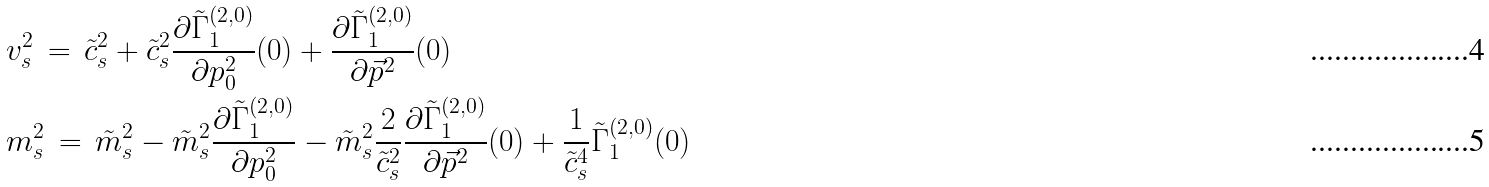Convert formula to latex. <formula><loc_0><loc_0><loc_500><loc_500>& v _ { s } ^ { 2 } \, = \, \tilde { c } _ { s } ^ { 2 } + \tilde { c } _ { s } ^ { 2 } \frac { \partial \tilde { \Gamma } ^ { ( 2 , 0 ) } _ { 1 } } { \partial p _ { 0 } ^ { 2 } } ( 0 ) + \frac { \partial \tilde { \Gamma } ^ { ( 2 , 0 ) } _ { 1 } } { \partial \vec { p } ^ { 2 } } ( 0 ) \\ & m _ { s } ^ { 2 } \, = \, \tilde { m } _ { s } ^ { 2 } - \tilde { m } _ { s } ^ { 2 } \frac { \partial \tilde { \Gamma } ^ { ( 2 , 0 ) } _ { 1 } } { \partial p _ { 0 } ^ { 2 } } - \tilde { m } _ { s } ^ { 2 } \frac { 2 } { \tilde { c } _ { s } ^ { 2 } } \frac { \partial \tilde { \Gamma } ^ { ( 2 , 0 ) } _ { 1 } } { \partial \vec { p } ^ { 2 } } ( 0 ) + \frac { 1 } { \tilde { c } _ { s } ^ { 4 } } \tilde { \Gamma } ^ { ( 2 , 0 ) } _ { 1 } ( 0 )</formula> 